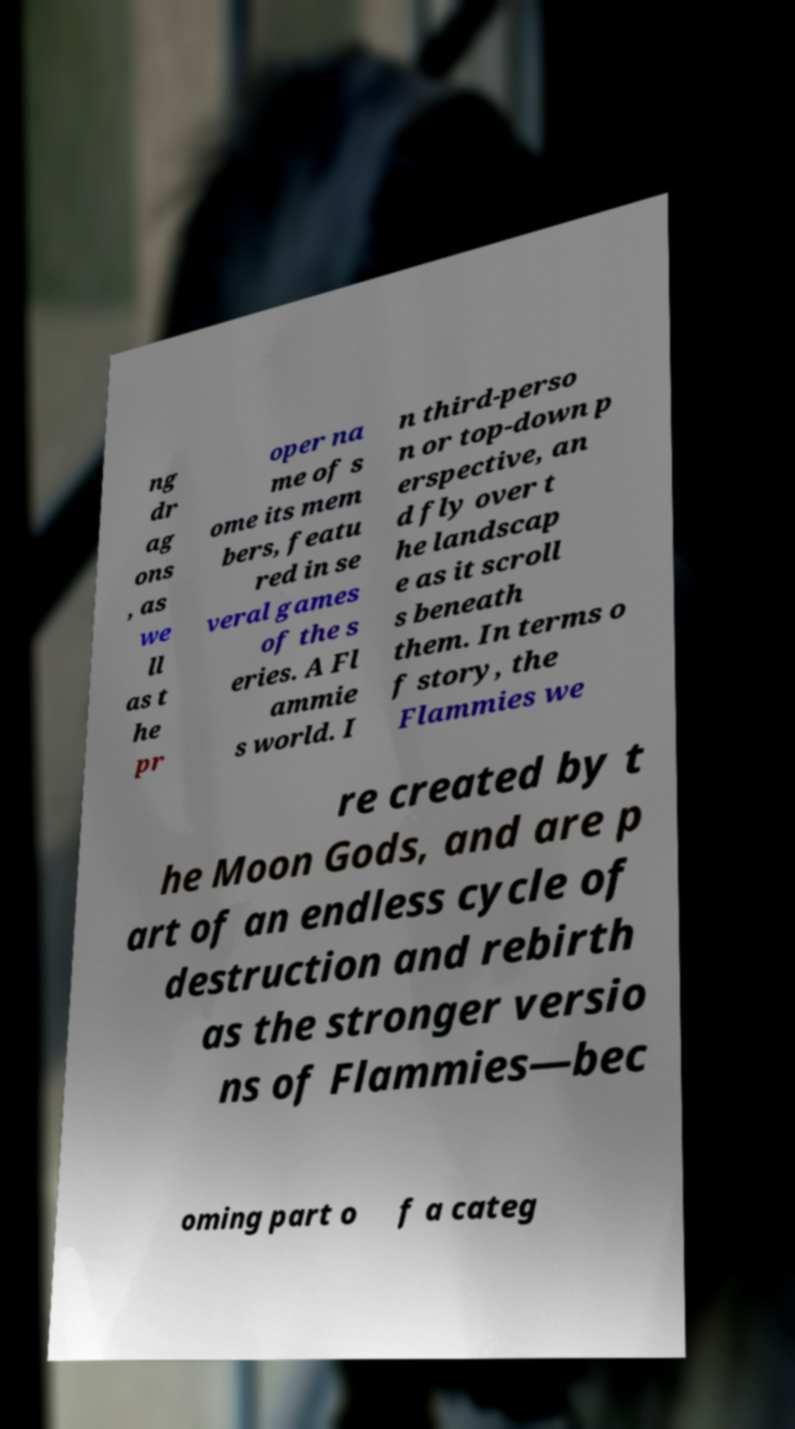Can you accurately transcribe the text from the provided image for me? ng dr ag ons , as we ll as t he pr oper na me of s ome its mem bers, featu red in se veral games of the s eries. A Fl ammie s world. I n third-perso n or top-down p erspective, an d fly over t he landscap e as it scroll s beneath them. In terms o f story, the Flammies we re created by t he Moon Gods, and are p art of an endless cycle of destruction and rebirth as the stronger versio ns of Flammies—bec oming part o f a categ 